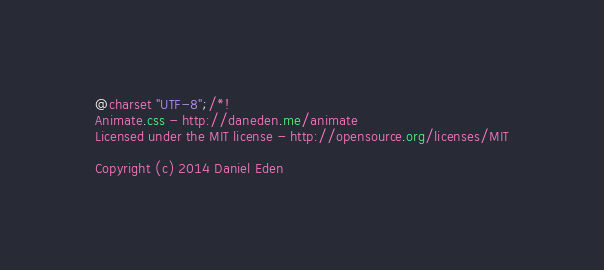Convert code to text. <code><loc_0><loc_0><loc_500><loc_500><_CSS_>@charset "UTF-8";/*!
Animate.css - http://daneden.me/animate
Licensed under the MIT license - http://opensource.org/licenses/MIT

Copyright (c) 2014 Daniel Eden</code> 